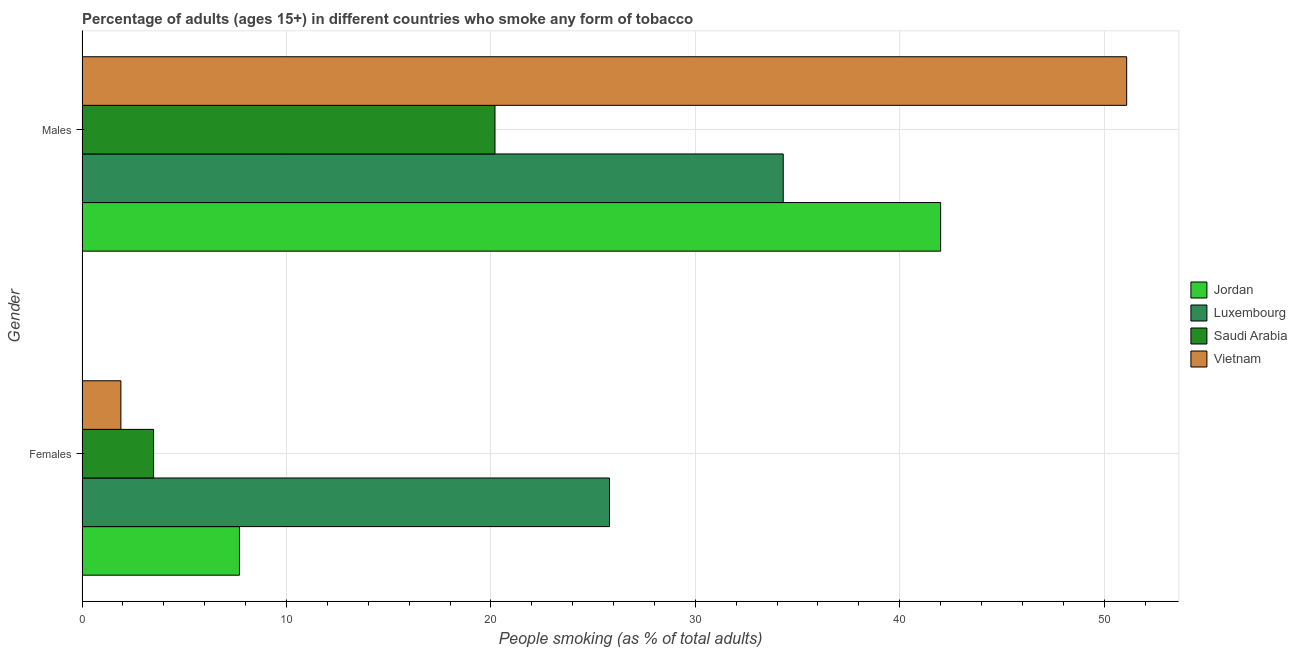How many different coloured bars are there?
Ensure brevity in your answer.  4. How many groups of bars are there?
Offer a very short reply. 2. What is the label of the 2nd group of bars from the top?
Ensure brevity in your answer.  Females. What is the percentage of males who smoke in Luxembourg?
Offer a very short reply. 34.3. Across all countries, what is the maximum percentage of females who smoke?
Offer a terse response. 25.8. In which country was the percentage of females who smoke maximum?
Your response must be concise. Luxembourg. In which country was the percentage of males who smoke minimum?
Offer a very short reply. Saudi Arabia. What is the total percentage of females who smoke in the graph?
Ensure brevity in your answer.  38.9. What is the difference between the percentage of males who smoke in Luxembourg and that in Saudi Arabia?
Make the answer very short. 14.1. What is the average percentage of males who smoke per country?
Your response must be concise. 36.9. What is the difference between the percentage of males who smoke and percentage of females who smoke in Jordan?
Give a very brief answer. 34.3. What is the ratio of the percentage of females who smoke in Saudi Arabia to that in Luxembourg?
Provide a short and direct response. 0.14. In how many countries, is the percentage of females who smoke greater than the average percentage of females who smoke taken over all countries?
Your answer should be compact. 1. What does the 1st bar from the top in Males represents?
Provide a succinct answer. Vietnam. What does the 4th bar from the bottom in Males represents?
Make the answer very short. Vietnam. Are all the bars in the graph horizontal?
Ensure brevity in your answer.  Yes. What is the difference between two consecutive major ticks on the X-axis?
Make the answer very short. 10. Does the graph contain any zero values?
Your response must be concise. No. What is the title of the graph?
Your response must be concise. Percentage of adults (ages 15+) in different countries who smoke any form of tobacco. What is the label or title of the X-axis?
Your answer should be compact. People smoking (as % of total adults). What is the label or title of the Y-axis?
Your answer should be compact. Gender. What is the People smoking (as % of total adults) in Luxembourg in Females?
Provide a succinct answer. 25.8. What is the People smoking (as % of total adults) in Saudi Arabia in Females?
Your answer should be compact. 3.5. What is the People smoking (as % of total adults) of Vietnam in Females?
Make the answer very short. 1.9. What is the People smoking (as % of total adults) of Luxembourg in Males?
Make the answer very short. 34.3. What is the People smoking (as % of total adults) of Saudi Arabia in Males?
Give a very brief answer. 20.2. What is the People smoking (as % of total adults) in Vietnam in Males?
Offer a very short reply. 51.1. Across all Gender, what is the maximum People smoking (as % of total adults) in Jordan?
Keep it short and to the point. 42. Across all Gender, what is the maximum People smoking (as % of total adults) of Luxembourg?
Provide a short and direct response. 34.3. Across all Gender, what is the maximum People smoking (as % of total adults) of Saudi Arabia?
Offer a terse response. 20.2. Across all Gender, what is the maximum People smoking (as % of total adults) of Vietnam?
Provide a succinct answer. 51.1. Across all Gender, what is the minimum People smoking (as % of total adults) of Luxembourg?
Make the answer very short. 25.8. Across all Gender, what is the minimum People smoking (as % of total adults) of Saudi Arabia?
Provide a succinct answer. 3.5. What is the total People smoking (as % of total adults) in Jordan in the graph?
Offer a very short reply. 49.7. What is the total People smoking (as % of total adults) in Luxembourg in the graph?
Provide a short and direct response. 60.1. What is the total People smoking (as % of total adults) in Saudi Arabia in the graph?
Your response must be concise. 23.7. What is the difference between the People smoking (as % of total adults) in Jordan in Females and that in Males?
Offer a terse response. -34.3. What is the difference between the People smoking (as % of total adults) in Luxembourg in Females and that in Males?
Offer a terse response. -8.5. What is the difference between the People smoking (as % of total adults) of Saudi Arabia in Females and that in Males?
Your answer should be compact. -16.7. What is the difference between the People smoking (as % of total adults) of Vietnam in Females and that in Males?
Provide a short and direct response. -49.2. What is the difference between the People smoking (as % of total adults) in Jordan in Females and the People smoking (as % of total adults) in Luxembourg in Males?
Give a very brief answer. -26.6. What is the difference between the People smoking (as % of total adults) of Jordan in Females and the People smoking (as % of total adults) of Vietnam in Males?
Your response must be concise. -43.4. What is the difference between the People smoking (as % of total adults) of Luxembourg in Females and the People smoking (as % of total adults) of Saudi Arabia in Males?
Keep it short and to the point. 5.6. What is the difference between the People smoking (as % of total adults) of Luxembourg in Females and the People smoking (as % of total adults) of Vietnam in Males?
Your answer should be very brief. -25.3. What is the difference between the People smoking (as % of total adults) of Saudi Arabia in Females and the People smoking (as % of total adults) of Vietnam in Males?
Provide a succinct answer. -47.6. What is the average People smoking (as % of total adults) in Jordan per Gender?
Make the answer very short. 24.85. What is the average People smoking (as % of total adults) in Luxembourg per Gender?
Provide a short and direct response. 30.05. What is the average People smoking (as % of total adults) of Saudi Arabia per Gender?
Your response must be concise. 11.85. What is the average People smoking (as % of total adults) of Vietnam per Gender?
Your answer should be compact. 26.5. What is the difference between the People smoking (as % of total adults) in Jordan and People smoking (as % of total adults) in Luxembourg in Females?
Offer a terse response. -18.1. What is the difference between the People smoking (as % of total adults) of Luxembourg and People smoking (as % of total adults) of Saudi Arabia in Females?
Provide a succinct answer. 22.3. What is the difference between the People smoking (as % of total adults) of Luxembourg and People smoking (as % of total adults) of Vietnam in Females?
Provide a short and direct response. 23.9. What is the difference between the People smoking (as % of total adults) in Saudi Arabia and People smoking (as % of total adults) in Vietnam in Females?
Keep it short and to the point. 1.6. What is the difference between the People smoking (as % of total adults) of Jordan and People smoking (as % of total adults) of Luxembourg in Males?
Provide a short and direct response. 7.7. What is the difference between the People smoking (as % of total adults) of Jordan and People smoking (as % of total adults) of Saudi Arabia in Males?
Ensure brevity in your answer.  21.8. What is the difference between the People smoking (as % of total adults) in Luxembourg and People smoking (as % of total adults) in Saudi Arabia in Males?
Your answer should be very brief. 14.1. What is the difference between the People smoking (as % of total adults) of Luxembourg and People smoking (as % of total adults) of Vietnam in Males?
Keep it short and to the point. -16.8. What is the difference between the People smoking (as % of total adults) of Saudi Arabia and People smoking (as % of total adults) of Vietnam in Males?
Provide a succinct answer. -30.9. What is the ratio of the People smoking (as % of total adults) of Jordan in Females to that in Males?
Provide a succinct answer. 0.18. What is the ratio of the People smoking (as % of total adults) of Luxembourg in Females to that in Males?
Offer a very short reply. 0.75. What is the ratio of the People smoking (as % of total adults) of Saudi Arabia in Females to that in Males?
Your answer should be compact. 0.17. What is the ratio of the People smoking (as % of total adults) in Vietnam in Females to that in Males?
Ensure brevity in your answer.  0.04. What is the difference between the highest and the second highest People smoking (as % of total adults) in Jordan?
Provide a succinct answer. 34.3. What is the difference between the highest and the second highest People smoking (as % of total adults) in Luxembourg?
Ensure brevity in your answer.  8.5. What is the difference between the highest and the second highest People smoking (as % of total adults) in Vietnam?
Ensure brevity in your answer.  49.2. What is the difference between the highest and the lowest People smoking (as % of total adults) of Jordan?
Your answer should be very brief. 34.3. What is the difference between the highest and the lowest People smoking (as % of total adults) of Vietnam?
Provide a succinct answer. 49.2. 